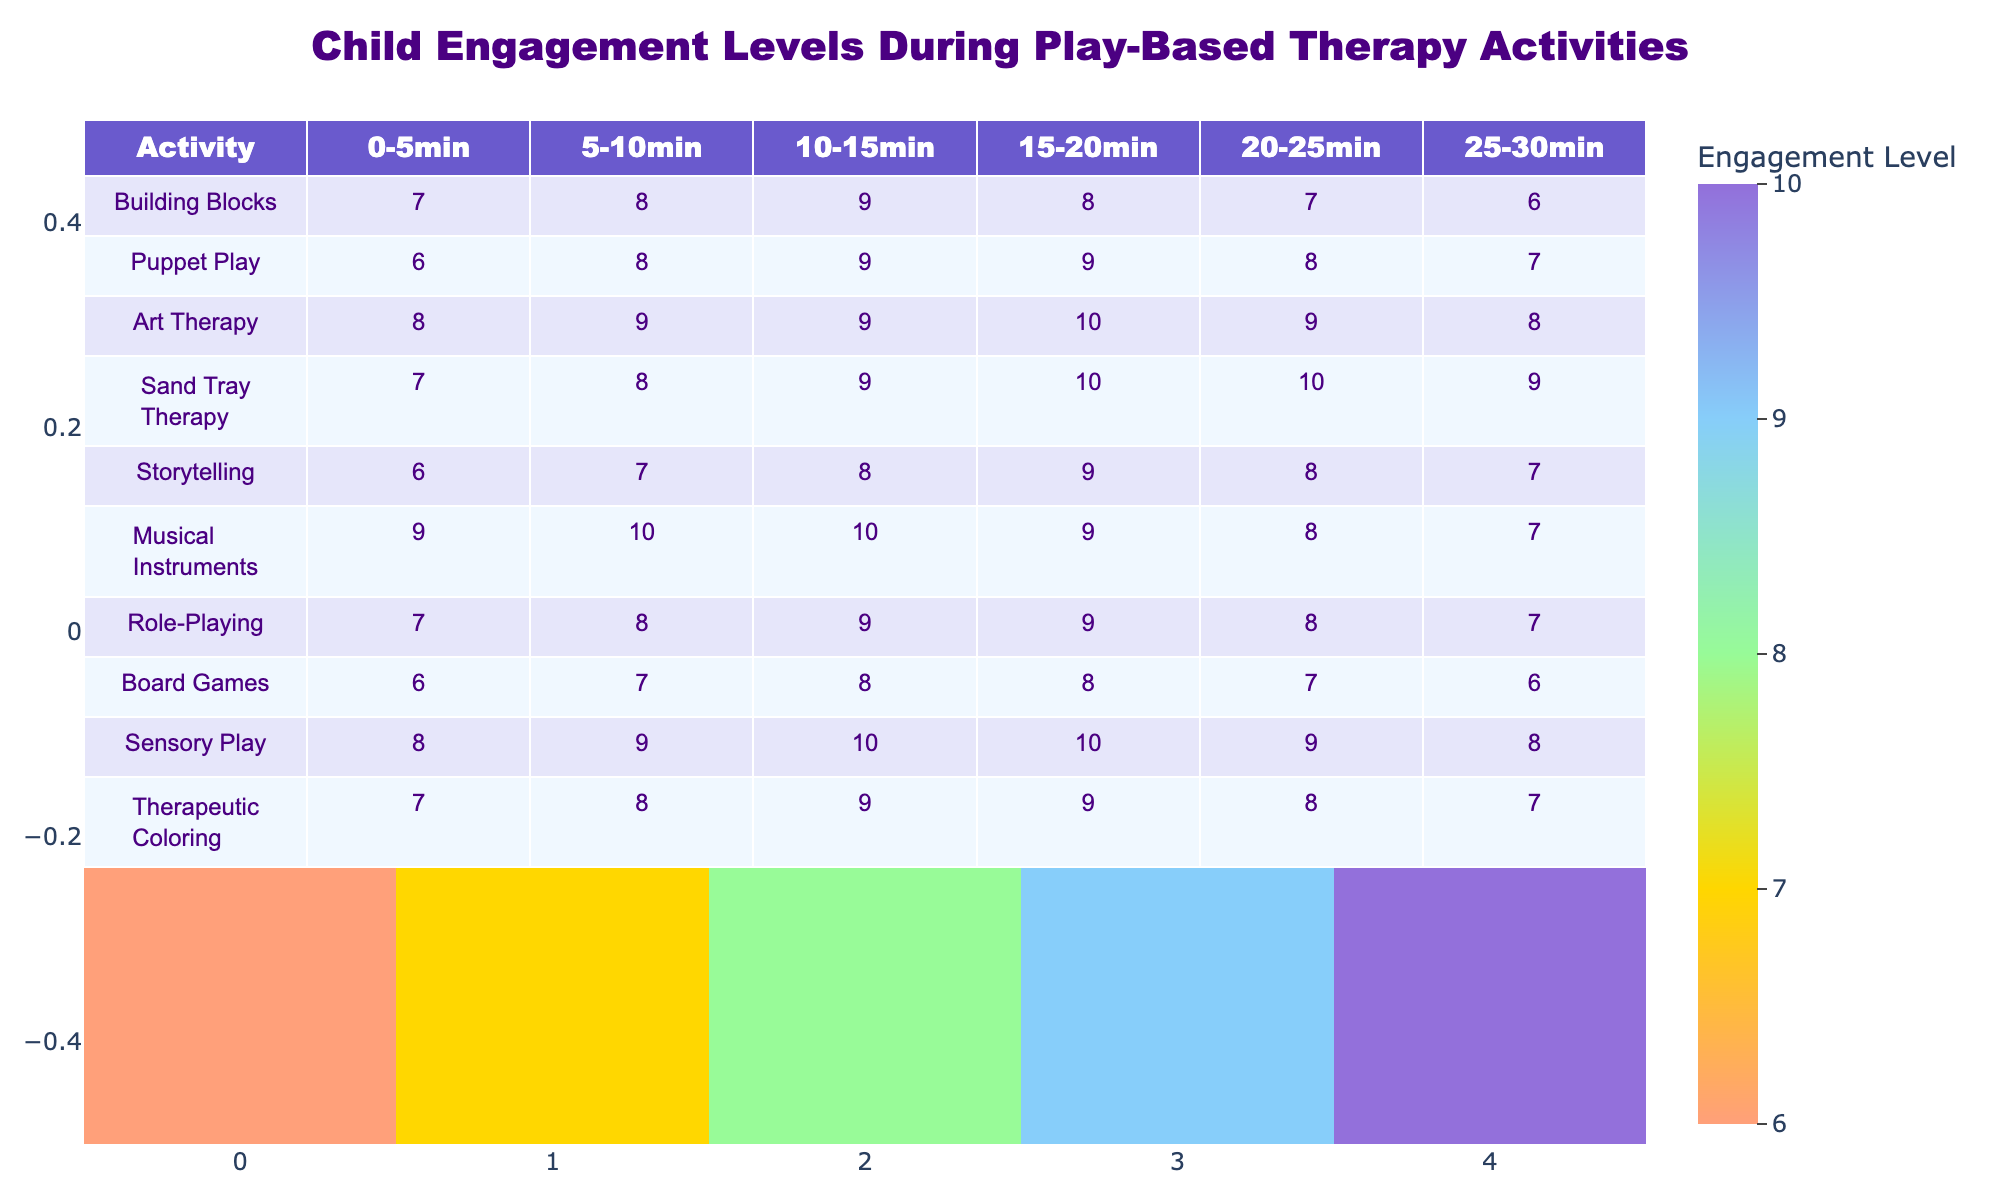What is the maximum engagement level recorded during the Art Therapy activity? The table shows the engagement levels for Art Therapy at different time intervals. Looking at the values, the highest engagement level is 10, which is seen in the 15-20 minute interval.
Answer: 10 Which activity had the lowest engagement level during the first 5 minutes? In the first 5-minute interval, we need to check the values across all activities. The lowest value recorded is 6 for Puppet Play and Board Games.
Answer: 6 What is the average engagement level for Sand Tray Therapy across all time intervals? We sum the engagement levels for Sand Tray Therapy: (7 + 8 + 9 + 10 + 10 + 9) = 53. There are 6 time intervals, so the average is 53/6 = 8.83.
Answer: 8.83 Was the engagement level in Musical Instruments consistently above 8 during the session? We check each time interval for Musical Instruments: 9, 10, 10, 9, 8, 7. The last two intervals show values of 8 and 7, which are not above 8. Thus, it is not consistent.
Answer: No What is the total engagement level for Sensory Play during the 20-30 minute interval? For Sensory Play, the engagement levels from the 20-30 minute interval are: 10 in 20-25 minutes and 9 in 25-30 minutes. Adding these gives a total of 10 + 9 = 19.
Answer: 19 How does the engagement level in Storytelling compare to Puppet Play at the 10-15 minute mark? At the 10-15 minute mark, Storytelling has an engagement level of 8, while Puppet Play has an engagement level of 9. Since 9 is greater than 8, Puppet Play has a higher level.
Answer: Puppet Play is higher What is the difference in engagement levels between the maximum and minimum during Role-Playing? The maximum engagement level during Role-Playing is 9 (at 10-15 and 15-20 minutes) and the minimum is 7 (at 0-5 and 25-30 minutes). The difference is 9 - 7 = 2.
Answer: 2 Which activity shows the highest engagement level during the 25-30 minute interval? We look at the engagement levels for all activities at the 25-30 minute interval. The highest engagement level is 7, recorded in Puppet Play, Musical Instruments, and Role-Playing.
Answer: 7 How many activities had an engagement level of 8 or higher in the 5-10 minute interval? By checking the values in the 5-10 minute interval: Building Blocks (8), Puppet Play (8), Art Therapy (9), Sand Tray Therapy (8), Musical Instruments (10), Role-Playing (8), Sensory Play (9), and Therapeutic Coloring (8). There are 8 activities with 8 or higher.
Answer: 8 What trend do you notice in the engagement levels of Art Therapy over time? The engagement levels for Art Therapy are: 8, 9, 9, 10, 9, 8. They generally increase from the first to the fourth interval, peak at 10, and then decrease in the last two intervals.
Answer: Initially increases, peaks, then decreases 